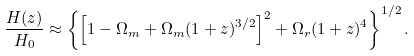<formula> <loc_0><loc_0><loc_500><loc_500>\frac { H ( z ) } { H _ { 0 } } \approx \left \{ \left [ 1 - \Omega _ { m } + \Omega _ { m } ( 1 + z ) ^ { 3 / 2 } \right ] ^ { 2 } + \Omega _ { r } ( 1 + z ) ^ { 4 } \right \} ^ { 1 / 2 } .</formula> 